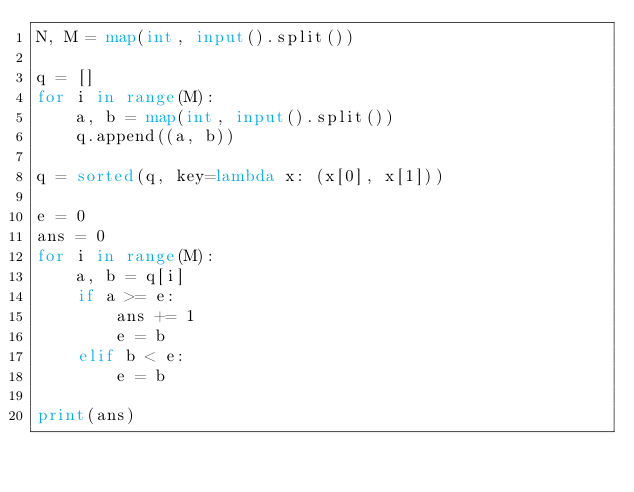Convert code to text. <code><loc_0><loc_0><loc_500><loc_500><_Python_>N, M = map(int, input().split())

q = []
for i in range(M):
    a, b = map(int, input().split())
    q.append((a, b))

q = sorted(q, key=lambda x: (x[0], x[1]))

e = 0
ans = 0
for i in range(M):
    a, b = q[i]
    if a >= e:
        ans += 1
        e = b
    elif b < e:
        e = b

print(ans)
</code> 